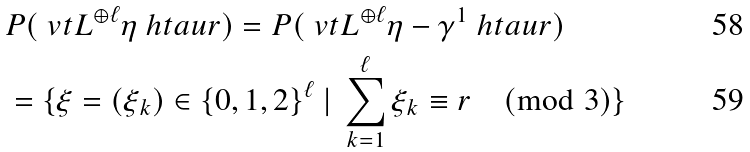Convert formula to latex. <formula><loc_0><loc_0><loc_500><loc_500>& P ( \ v t { L ^ { \oplus { \ell } } } { \eta } { \ h t a u } { r } ) = P ( \ v t { L ^ { \oplus { \ell } } } { \eta - \gamma ^ { 1 } } { \ h t a u } { r } ) \\ & = \{ \xi = ( \xi _ { k } ) \in \{ 0 , 1 , 2 \} ^ { \ell } \ | \ \sum _ { k = 1 } ^ { \ell } \xi _ { k } \equiv r \pmod { 3 } \}</formula> 